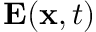<formula> <loc_0><loc_0><loc_500><loc_500>E ( { x } , t )</formula> 